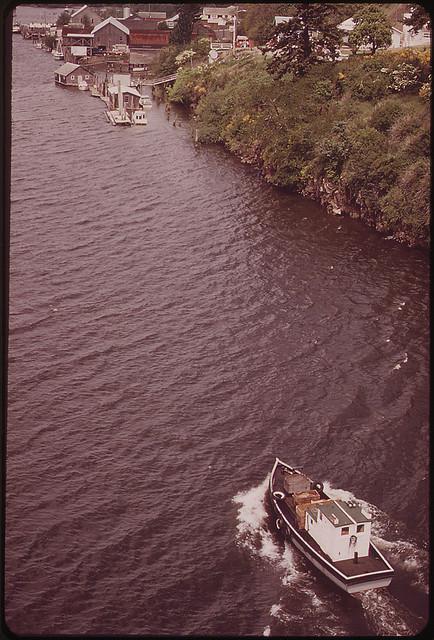How many boats?
Give a very brief answer. 1. How many people are on the pommel lift?
Give a very brief answer. 0. 